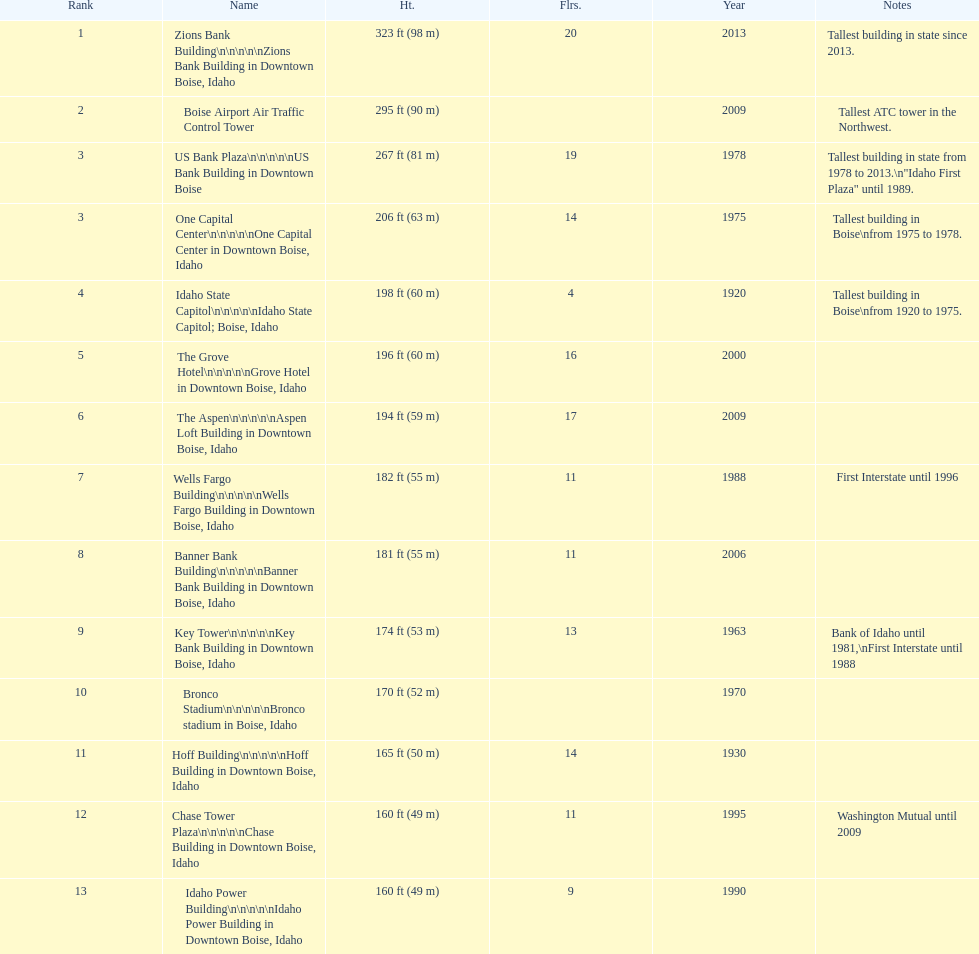What is the number of floors of the oldest building? 4. 